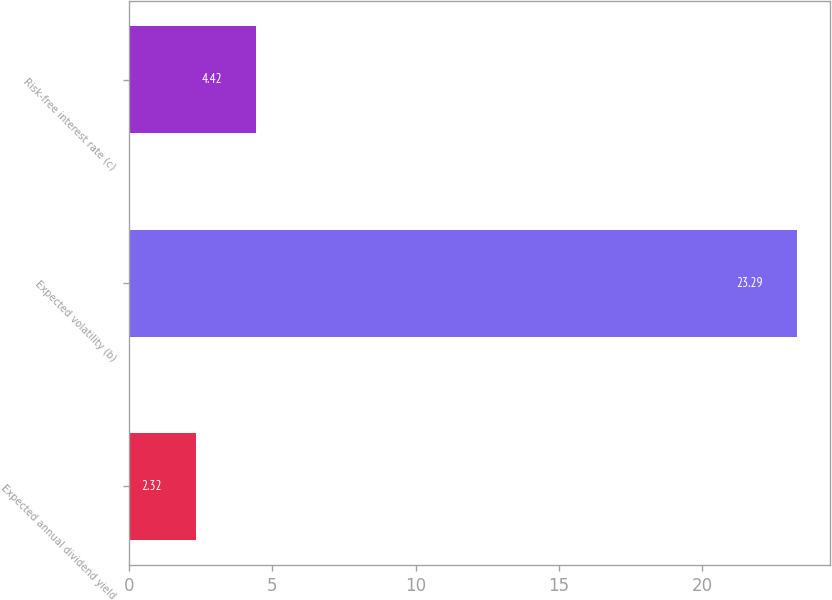<chart> <loc_0><loc_0><loc_500><loc_500><bar_chart><fcel>Expected annual dividend yield<fcel>Expected volatility (b)<fcel>Risk-free interest rate (c)<nl><fcel>2.32<fcel>23.29<fcel>4.42<nl></chart> 